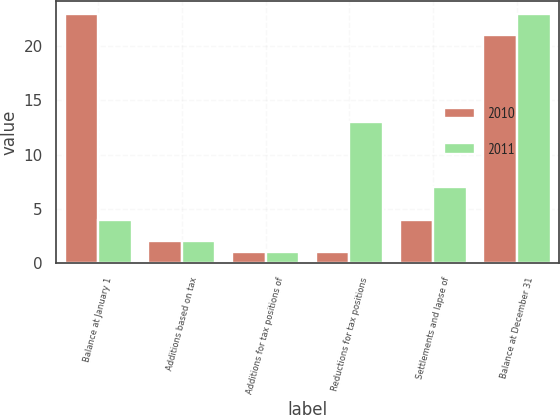Convert chart. <chart><loc_0><loc_0><loc_500><loc_500><stacked_bar_chart><ecel><fcel>Balance at January 1<fcel>Additions based on tax<fcel>Additions for tax positions of<fcel>Reductions for tax positions<fcel>Settlements and lapse of<fcel>Balance at December 31<nl><fcel>2010<fcel>23<fcel>2<fcel>1<fcel>1<fcel>4<fcel>21<nl><fcel>2011<fcel>4<fcel>2<fcel>1<fcel>13<fcel>7<fcel>23<nl></chart> 